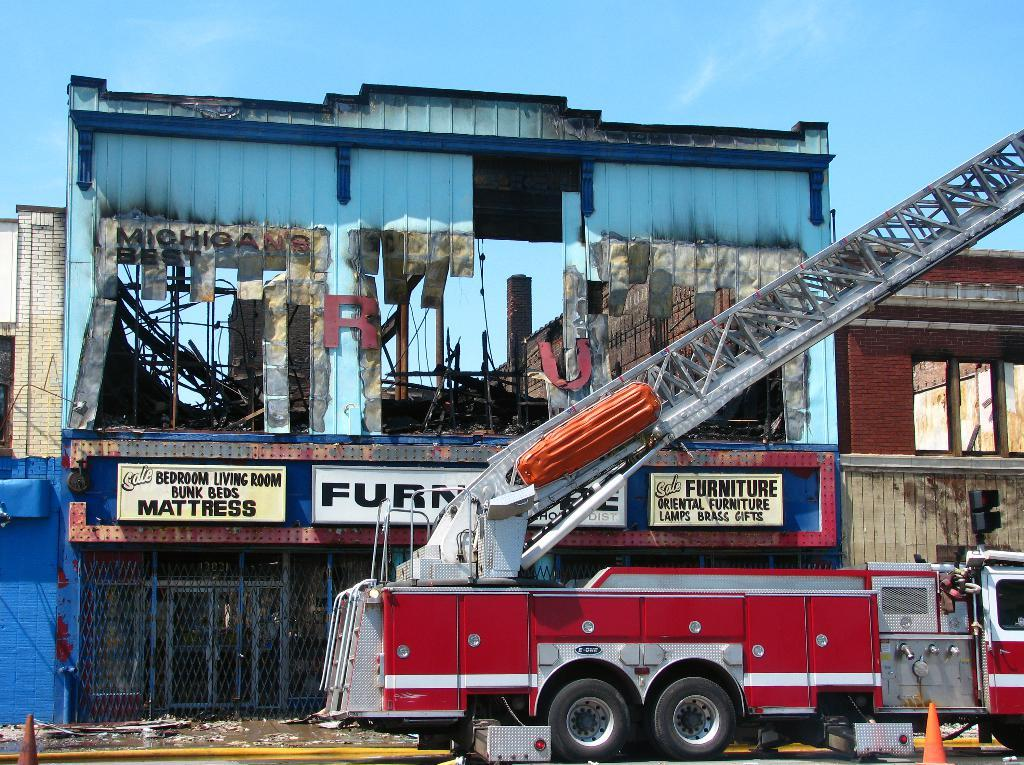What is the main subject of the image? The main subject of the image is a fire truck. Where is the fire truck located in relation to other objects in the image? The fire truck is in front of a building. How long does it take for the cup to be filled with water from the fire truck's hose in the image? There is no cup present in the image, and the fire truck's hose is not shown in use, so it is impossible to determine how long it would take to fill a cup with water. 